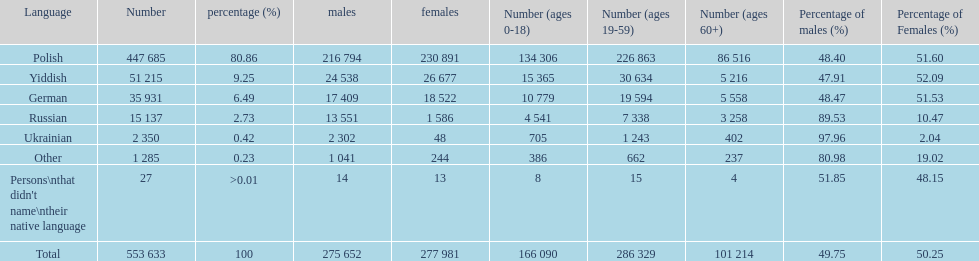Which is the least spoken language? Ukrainian. 